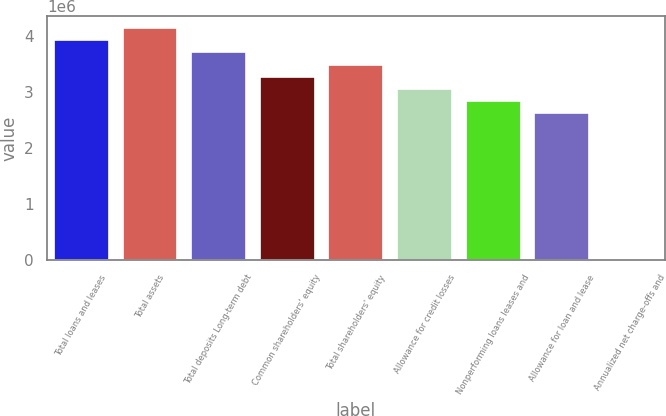Convert chart. <chart><loc_0><loc_0><loc_500><loc_500><bar_chart><fcel>Total loans and leases<fcel>Total assets<fcel>Total deposits Long-term debt<fcel>Common shareholders' equity<fcel>Total shareholders' equity<fcel>Allowance for credit losses<fcel>Nonperforming loans leases and<fcel>Allowance for loan and lease<fcel>Annualized net charge-offs and<nl><fcel>3.9323e+06<fcel>4.15076e+06<fcel>3.71384e+06<fcel>3.27691e+06<fcel>3.49538e+06<fcel>3.05845e+06<fcel>2.83999e+06<fcel>2.62153e+06<fcel>1.07<nl></chart> 